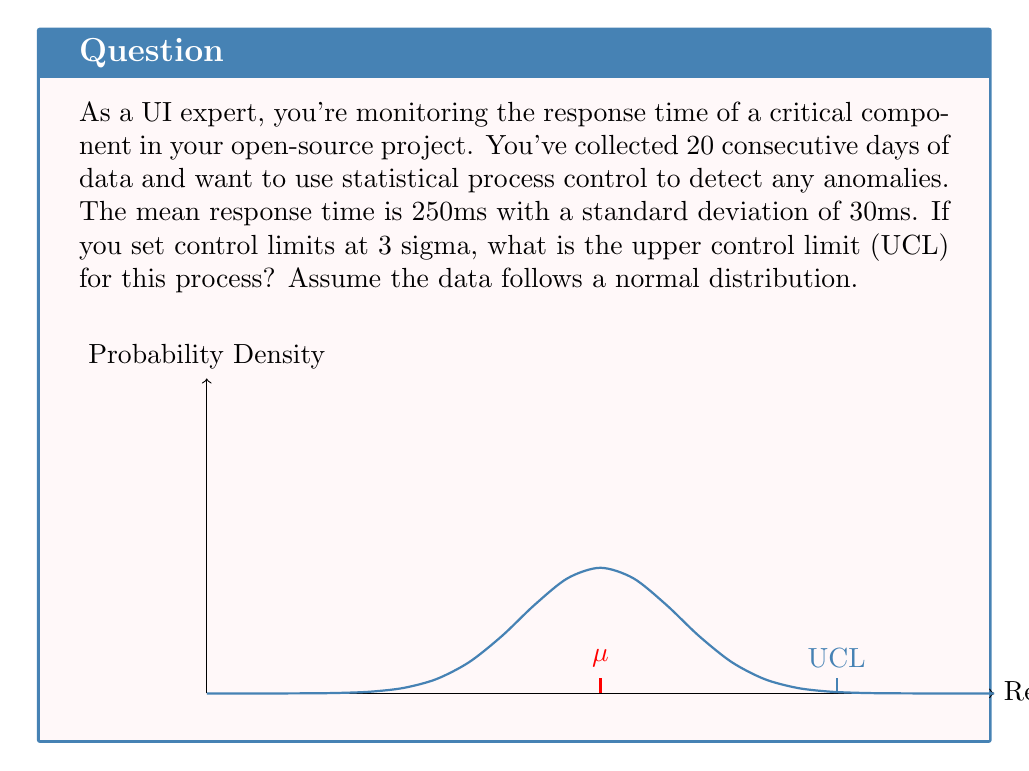Teach me how to tackle this problem. To solve this problem, we'll use the concept of control limits in statistical process control (SPC). The upper control limit (UCL) is typically set at 3 standard deviations above the mean.

Given:
- Mean response time ($\mu$) = 250 ms
- Standard deviation ($\sigma$) = 30 ms
- Control limits are set at 3 sigma

Step 1: Calculate the UCL using the formula:
$$UCL = \mu + 3\sigma$$

Step 2: Substitute the given values:
$$UCL = 250 + 3(30)$$

Step 3: Perform the calculation:
$$UCL = 250 + 90 = 340$$

Therefore, the upper control limit (UCL) for this process is 340 ms.

This means that any response time above 340 ms would be considered an anomaly in the UI performance data, warranting further investigation or action.
Answer: 340 ms 